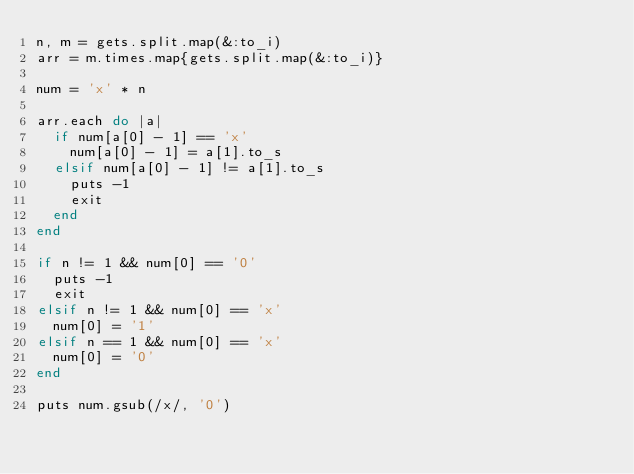Convert code to text. <code><loc_0><loc_0><loc_500><loc_500><_Ruby_>n, m = gets.split.map(&:to_i)
arr = m.times.map{gets.split.map(&:to_i)}

num = 'x' * n

arr.each do |a|
  if num[a[0] - 1] == 'x'
    num[a[0] - 1] = a[1].to_s
  elsif num[a[0] - 1] != a[1].to_s
    puts -1
    exit
  end
end

if n != 1 && num[0] == '0'
  puts -1
  exit
elsif n != 1 && num[0] == 'x'
  num[0] = '1'
elsif n == 1 && num[0] == 'x'
  num[0] = '0'
end

puts num.gsub(/x/, '0')</code> 